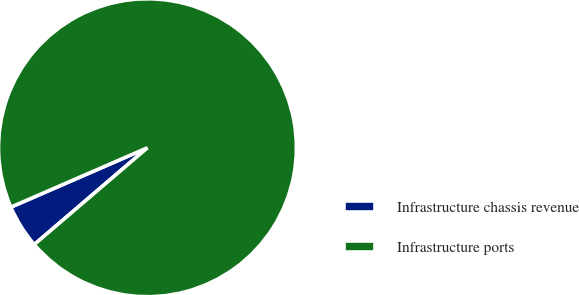Convert chart to OTSL. <chart><loc_0><loc_0><loc_500><loc_500><pie_chart><fcel>Infrastructure chassis revenue<fcel>Infrastructure ports<nl><fcel>4.73%<fcel>95.27%<nl></chart> 